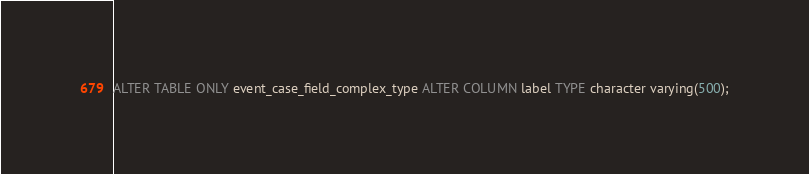<code> <loc_0><loc_0><loc_500><loc_500><_SQL_>ALTER TABLE ONLY event_case_field_complex_type ALTER COLUMN label TYPE character varying(500);
</code> 